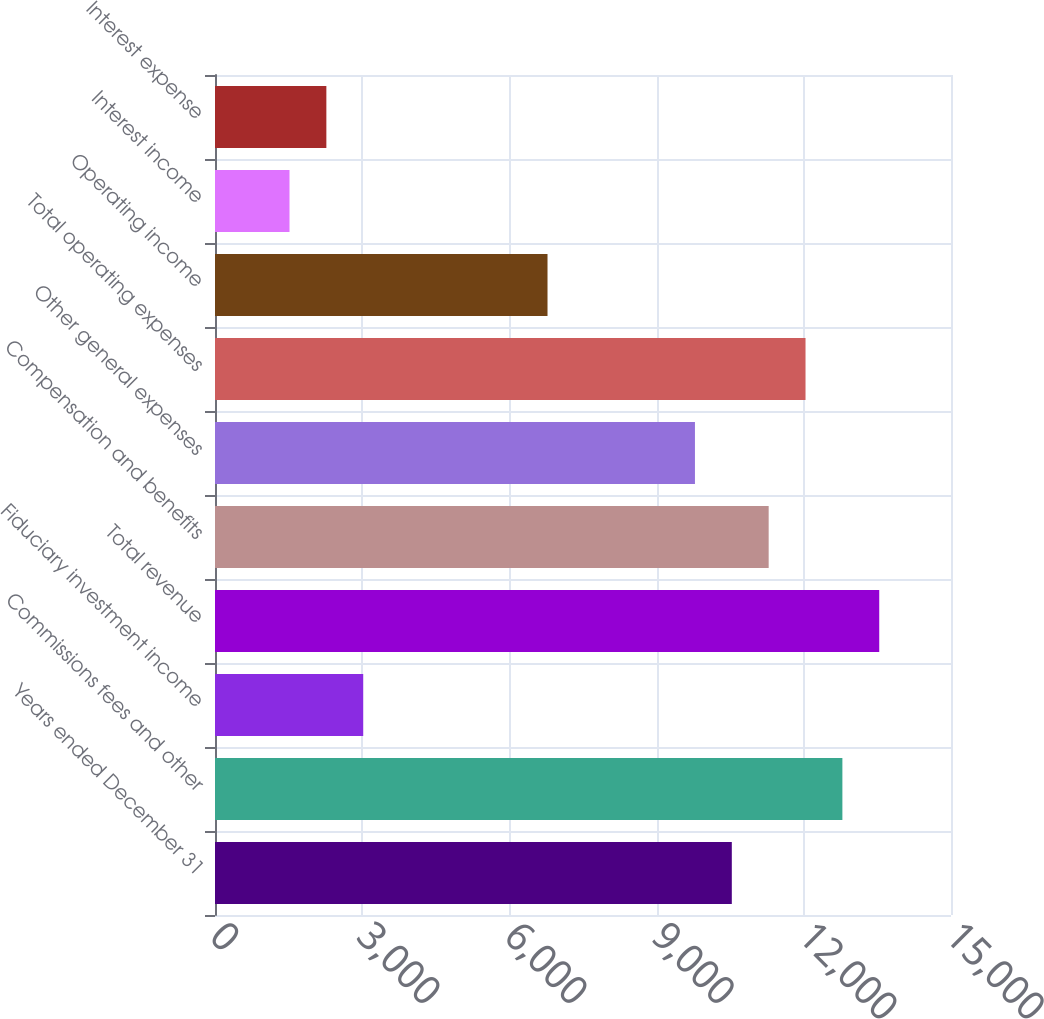Convert chart. <chart><loc_0><loc_0><loc_500><loc_500><bar_chart><fcel>Years ended December 31<fcel>Commissions fees and other<fcel>Fiduciary investment income<fcel>Total revenue<fcel>Compensation and benefits<fcel>Other general expenses<fcel>Total operating expenses<fcel>Operating income<fcel>Interest income<fcel>Interest expense<nl><fcel>10532.8<fcel>12786.4<fcel>3020.8<fcel>13537.6<fcel>11284<fcel>9781.6<fcel>12035.2<fcel>6776.8<fcel>1518.4<fcel>2269.6<nl></chart> 